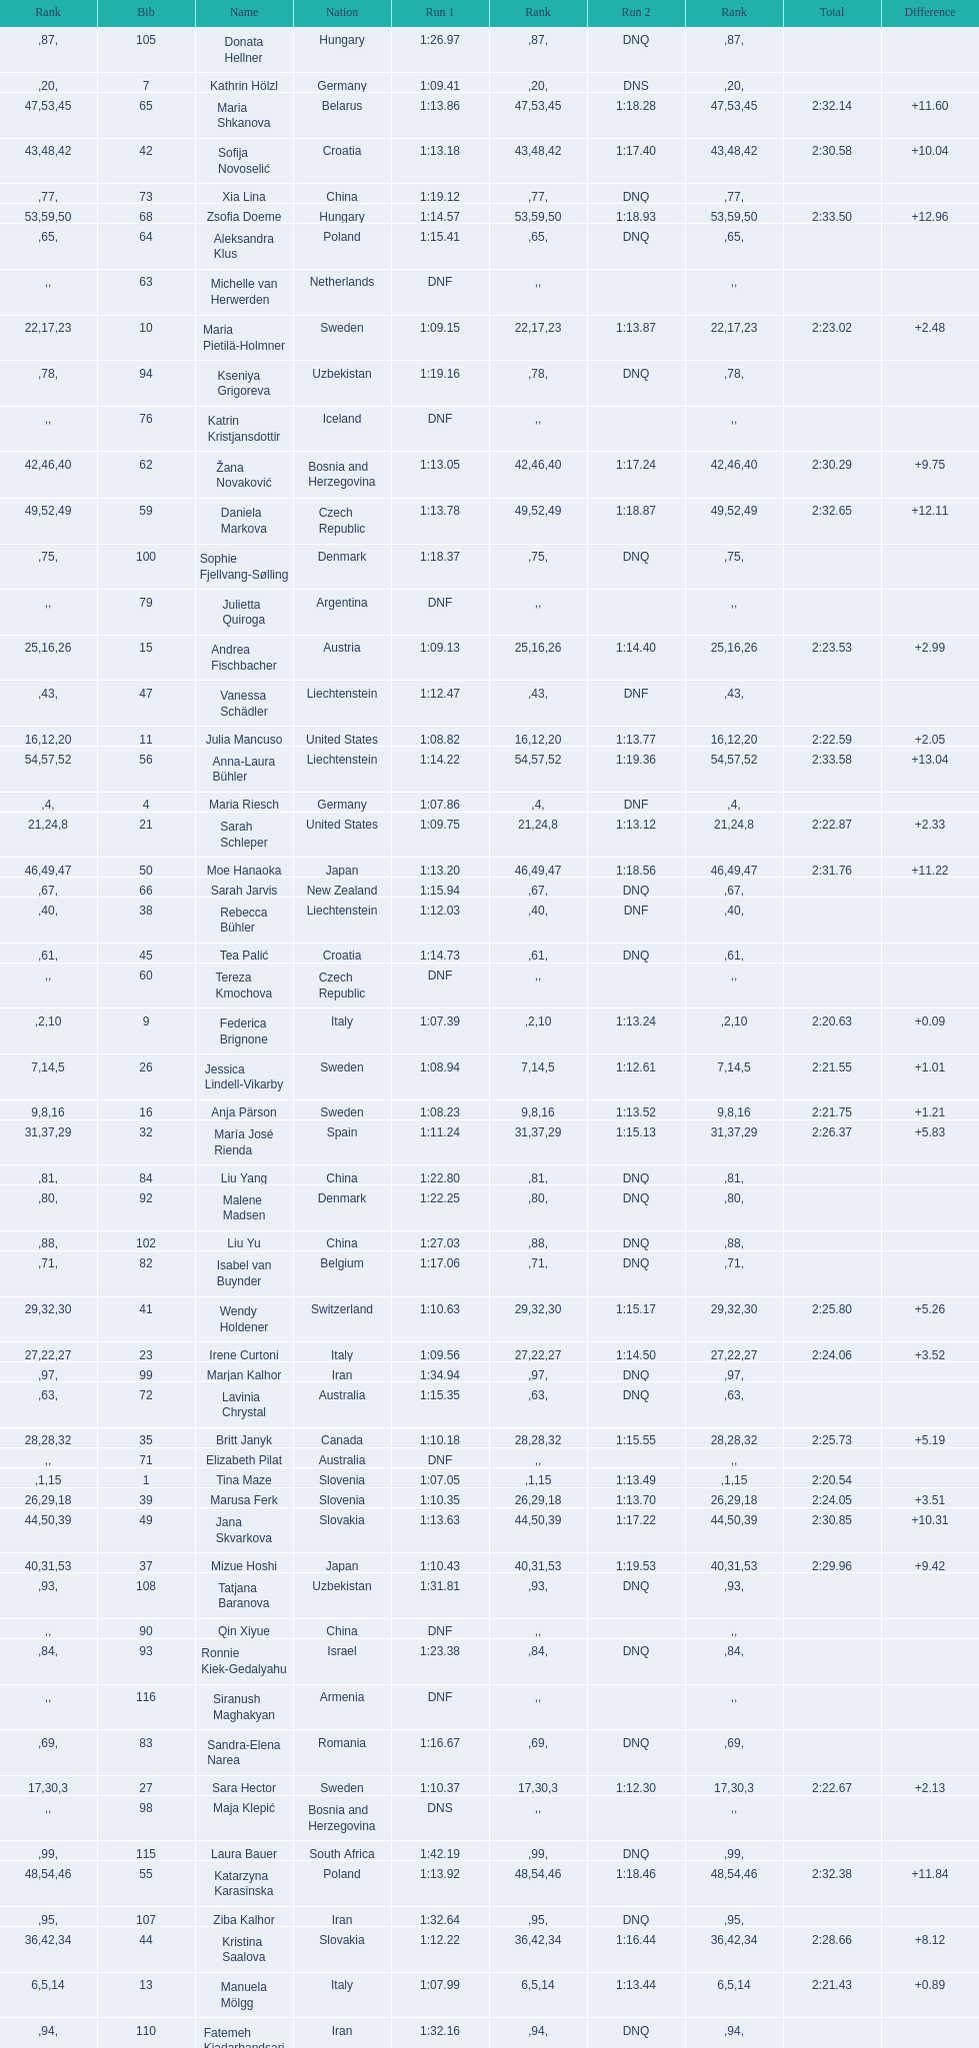How many total names are there? 116. Can you parse all the data within this table? {'header': ['Rank', 'Bib', 'Name', 'Nation', 'Run 1', 'Rank', 'Run 2', 'Rank', 'Total', 'Difference'], 'rows': [['', '105', 'Donata Hellner', 'Hungary', '1:26.97', '87', 'DNQ', '', '', ''], ['', '7', 'Kathrin Hölzl', 'Germany', '1:09.41', '20', 'DNS', '', '', ''], ['47', '65', 'Maria Shkanova', 'Belarus', '1:13.86', '53', '1:18.28', '45', '2:32.14', '+11.60'], ['43', '42', 'Sofija Novoselić', 'Croatia', '1:13.18', '48', '1:17.40', '42', '2:30.58', '+10.04'], ['', '73', 'Xia Lina', 'China', '1:19.12', '77', 'DNQ', '', '', ''], ['53', '68', 'Zsofia Doeme', 'Hungary', '1:14.57', '59', '1:18.93', '50', '2:33.50', '+12.96'], ['', '64', 'Aleksandra Klus', 'Poland', '1:15.41', '65', 'DNQ', '', '', ''], ['', '63', 'Michelle van Herwerden', 'Netherlands', 'DNF', '', '', '', '', ''], ['22', '10', 'Maria Pietilä-Holmner', 'Sweden', '1:09.15', '17', '1:13.87', '23', '2:23.02', '+2.48'], ['', '94', 'Kseniya Grigoreva', 'Uzbekistan', '1:19.16', '78', 'DNQ', '', '', ''], ['', '76', 'Katrin Kristjansdottir', 'Iceland', 'DNF', '', '', '', '', ''], ['42', '62', 'Žana Novaković', 'Bosnia and Herzegovina', '1:13.05', '46', '1:17.24', '40', '2:30.29', '+9.75'], ['49', '59', 'Daniela Markova', 'Czech Republic', '1:13.78', '52', '1:18.87', '49', '2:32.65', '+12.11'], ['', '100', 'Sophie Fjellvang-Sølling', 'Denmark', '1:18.37', '75', 'DNQ', '', '', ''], ['', '79', 'Julietta Quiroga', 'Argentina', 'DNF', '', '', '', '', ''], ['25', '15', 'Andrea Fischbacher', 'Austria', '1:09.13', '16', '1:14.40', '26', '2:23.53', '+2.99'], ['', '47', 'Vanessa Schädler', 'Liechtenstein', '1:12.47', '43', 'DNF', '', '', ''], ['16', '11', 'Julia Mancuso', 'United States', '1:08.82', '12', '1:13.77', '20', '2:22.59', '+2.05'], ['54', '56', 'Anna-Laura Bühler', 'Liechtenstein', '1:14.22', '57', '1:19.36', '52', '2:33.58', '+13.04'], ['', '4', 'Maria Riesch', 'Germany', '1:07.86', '4', 'DNF', '', '', ''], ['21', '21', 'Sarah Schleper', 'United States', '1:09.75', '24', '1:13.12', '8', '2:22.87', '+2.33'], ['46', '50', 'Moe Hanaoka', 'Japan', '1:13.20', '49', '1:18.56', '47', '2:31.76', '+11.22'], ['', '66', 'Sarah Jarvis', 'New Zealand', '1:15.94', '67', 'DNQ', '', '', ''], ['', '38', 'Rebecca Bühler', 'Liechtenstein', '1:12.03', '40', 'DNF', '', '', ''], ['', '45', 'Tea Palić', 'Croatia', '1:14.73', '61', 'DNQ', '', '', ''], ['', '60', 'Tereza Kmochova', 'Czech Republic', 'DNF', '', '', '', '', ''], ['', '9', 'Federica Brignone', 'Italy', '1:07.39', '2', '1:13.24', '10', '2:20.63', '+0.09'], ['7', '26', 'Jessica Lindell-Vikarby', 'Sweden', '1:08.94', '14', '1:12.61', '5', '2:21.55', '+1.01'], ['9', '16', 'Anja Pärson', 'Sweden', '1:08.23', '8', '1:13.52', '16', '2:21.75', '+1.21'], ['31', '32', 'María José Rienda', 'Spain', '1:11.24', '37', '1:15.13', '29', '2:26.37', '+5.83'], ['', '84', 'Liu Yang', 'China', '1:22.80', '81', 'DNQ', '', '', ''], ['', '92', 'Malene Madsen', 'Denmark', '1:22.25', '80', 'DNQ', '', '', ''], ['', '102', 'Liu Yu', 'China', '1:27.03', '88', 'DNQ', '', '', ''], ['', '82', 'Isabel van Buynder', 'Belgium', '1:17.06', '71', 'DNQ', '', '', ''], ['29', '41', 'Wendy Holdener', 'Switzerland', '1:10.63', '32', '1:15.17', '30', '2:25.80', '+5.26'], ['27', '23', 'Irene Curtoni', 'Italy', '1:09.56', '22', '1:14.50', '27', '2:24.06', '+3.52'], ['', '99', 'Marjan Kalhor', 'Iran', '1:34.94', '97', 'DNQ', '', '', ''], ['', '72', 'Lavinia Chrystal', 'Australia', '1:15.35', '63', 'DNQ', '', '', ''], ['28', '35', 'Britt Janyk', 'Canada', '1:10.18', '28', '1:15.55', '32', '2:25.73', '+5.19'], ['', '71', 'Elizabeth Pilat', 'Australia', 'DNF', '', '', '', '', ''], ['', '1', 'Tina Maze', 'Slovenia', '1:07.05', '1', '1:13.49', '15', '2:20.54', ''], ['26', '39', 'Marusa Ferk', 'Slovenia', '1:10.35', '29', '1:13.70', '18', '2:24.05', '+3.51'], ['44', '49', 'Jana Skvarkova', 'Slovakia', '1:13.63', '50', '1:17.22', '39', '2:30.85', '+10.31'], ['40', '37', 'Mizue Hoshi', 'Japan', '1:10.43', '31', '1:19.53', '53', '2:29.96', '+9.42'], ['', '108', 'Tatjana Baranova', 'Uzbekistan', '1:31.81', '93', 'DNQ', '', '', ''], ['', '90', 'Qin Xiyue', 'China', 'DNF', '', '', '', '', ''], ['', '93', 'Ronnie Kiek-Gedalyahu', 'Israel', '1:23.38', '84', 'DNQ', '', '', ''], ['', '116', 'Siranush Maghakyan', 'Armenia', 'DNF', '', '', '', '', ''], ['', '83', 'Sandra-Elena Narea', 'Romania', '1:16.67', '69', 'DNQ', '', '', ''], ['17', '27', 'Sara Hector', 'Sweden', '1:10.37', '30', '1:12.30', '3', '2:22.67', '+2.13'], ['', '98', 'Maja Klepić', 'Bosnia and Herzegovina', 'DNS', '', '', '', '', ''], ['', '115', 'Laura Bauer', 'South Africa', '1:42.19', '99', 'DNQ', '', '', ''], ['48', '55', 'Katarzyna Karasinska', 'Poland', '1:13.92', '54', '1:18.46', '46', '2:32.38', '+11.84'], ['', '107', 'Ziba Kalhor', 'Iran', '1:32.64', '95', 'DNQ', '', '', ''], ['36', '44', 'Kristina Saalova', 'Slovakia', '1:12.22', '42', '1:16.44', '34', '2:28.66', '+8.12'], ['6', '13', 'Manuela Mölgg', 'Italy', '1:07.99', '5', '1:13.44', '14', '2:21.43', '+0.89'], ['', '110', 'Fatemeh Kiadarbandsari', 'Iran', '1:32.16', '94', 'DNQ', '', '', ''], ['', '69', 'Iris Gudmundsdottir', 'Iceland', '1:13.93', '55', 'DNF', '', '', ''], ['38', '52', 'Jana Gantnerova', 'Slovakia', '1:12.01', '39', '1:17.29', '41', '2:29.30', '+8.76'], ['20', '17', 'Lara Gut', 'Switzerland', '1:08.91', '13', '1:13.92', '24', '2:22.83', '+2.29'], ['50', '58', 'Nevena Ignjatović', 'Serbia', '1:14.38', '58', '1:18.56', '47', '2:32.94', '+12.40'], ['', '95', 'Ornella Oettl Reyes', 'Peru', '1:18.61', '76', 'DNQ', '', '', ''], ['', '75', 'Salome Bancora', 'Argentina', '1:23.08', '83', 'DNQ', '', '', ''], ['', '88', 'Nicole Valcareggi', 'Greece', '1:18.19', '74', 'DNQ', '', '', ''], ['', '33', 'Agniezska Gasienica Daniel', 'Poland', 'DNF', '', '', '', '', ''], ['', '104', 'Paraskevi Mavridou', 'Greece', '1:32.83', '96', 'DNQ', '', '', ''], ['', '106', 'Svetlana Baranova', 'Uzbekistan', '1:30.62', '92', 'DNQ', '', '', ''], ['41', '34', 'Emi Hasegawa', 'Japan', '1:12.67', '44', '1:17.58', '43', '2:30.25', '+9.71'], ['19', '29', 'Anne-Sophie Barthet', 'France', '1:09.55', '21', '1:13.18', '9', '2:22.73', '+2.19'], ['', '113', 'Anne Libak Nielsen', 'Denmark', '1:25.08', '86', 'DNQ', '', '', ''], ['', '18', 'Fabienne Suter', 'Switzerland', 'DNS', '', '', '', '', ''], ['14', '12', 'Anemone Marmottan', 'France', '1:08.54', '10', '1:13.80', '21', '2:22.34', '+1.80'], ['18', '24', 'Lena Dürr', 'Germany', '1:08.94', '14', '1:13.75', '19', '2:22.69', '+2.15'], ['4', '20', 'Denise Karbon', 'Italy', '1:08.24', '9', '1:13.04', '7', '2:21.28', '+0.74'], ['', '96', 'Chiara Marano', 'Brazil', '1:24.16', '85', 'DNQ', '', '', ''], ['', '111', 'Sarah Ekmekejian', 'Lebanon', '1:42.22', '100', 'DNQ', '', '', ''], ['52', '77', 'Bogdana Matsotska', 'Ukraine', '1:14.21', '56', '1:19.18', '51', '2:33.39', '+12.85'], ['30', '28', 'Veronika Staber', 'Germany', '1:10.80', '33', '1:15.16', '28', '2:25.96', '+5.42'], ['', '78', 'Nino Tsiklauri', 'Georgia', '1:15.54', '66', 'DNQ', '', '', ''], ['', '70', 'Maya Harrisson', 'Brazil', 'DNF', '', '', '', '', ''], ['8', '19', 'Marlies Schild', 'Austria', '1:09.16', '18', '1:12.58', '4', '2:21.74', '+1.20'], ['5', '6', 'Viktoria Rebensburg', 'Germany', '1:08.04', '6', '1:13.38', '13', '2:21.42', '+0.88'], ['', '91', 'Yom Hirshfeld', 'Israel', '1:22.87', '82', 'DNQ', '', '', ''], ['', '85', 'Iulia Petruta Craciun', 'Romania', '1:16.80', '70', 'DNQ', '', '', ''], ['45', '40', 'Maria Belen Simari Birkner', 'Argentina', '1:13.14', '47', '1:17.84', '44', '2:30.98', '+10.44'], ['23', '22', 'Marie-Michèle Gagnon', 'Canada', '1:09.95', '27', '1:13.37', '12', '2:23.32', '+2.78'], ['37', '51', 'Katerina Paulathova', 'Czech Republic', '1:12.10', '41', '1:16.71', '38', '2:28.81', '+8.27'], ['51', '80', 'Maria Kirkova', 'Bulgaria', '1:13.70', '51', '1:19.56', '54', '2:33.26', '+12.72'], ['39', '46', 'Vladislava Bureeva', 'Russia', '1:12.83', '45', '1:16.63', '37', '2:29.46', '+8.92'], ['13', '2', 'Tanja Poutiainen', 'Finland', '1:08.59', '11', '1:13.29', '11', '2:21.88', '+1.34'], ['10', '8', 'Elisabeth Görgl', 'Austria', '1:07.76', '3', '1:14.03', '25', '2:21.79', '+1.25'], ['12', '5', 'Kathrin Zettel', 'Austria', '1:08.04', '6', '1:13.80', '21', '2:21.84', '+1.30'], ['', '81', 'Lelde Gasuna', 'Latvia', '1:15.37', '64', 'DNQ', '', '', ''], ['', '86', 'Kristina Krone', 'Puerto Rico', '1:17.93', '73', 'DNQ', '', '', ''], ['', '103', 'Szelina Hellner', 'Hungary', '1:27.27', '90', 'DNQ', '', '', ''], ['15', '31', 'Veronika Zuzulova', 'Slovakia', '1:09.76', '25', '1:12.81', '6', '2:22.57', '+2.03'], ['33', '36', 'Carolina Ruiz Castillo', 'Spain', '1:10.93', '34', '1:15.98', '33', '2:26.91', '+6.37'], ['10', '14', 'Taïna Barioz', 'France', '1:09.59', '23', '1:12.20', '2', '2:21.79', '+1.25'], ['', '87', 'Tugba Dasdemir', 'Turkey', '1:21.50', '79', 'DNQ', '', '', ''], ['34', '30', 'Megan McJames', 'United States', '1:11.13', '36', '1:16.49', '35', '2:27.62', '+7.08'], ['', '74', 'Macarena Simari Birkner', 'Argentina', '1:15.18', '62', 'DNQ', '', '', ''], ['', '57', 'Brittany Phelan', 'Canada', 'DNF', '', '', '', '', ''], ['', '114', 'Irina Volkova', 'Kyrgyzstan', '1:29.73', '91', 'DNQ', '', '', ''], ['', '54', 'Mireia Gutierrez', 'Andorra', 'DNF', '', '', '', '', ''], ['', '89', 'Evija Benhena', 'Latvia', 'DNF', '', '', '', '', ''], ['35', '43', 'Denise Feierabend', 'Switzerland', '1:11.37', '38', '1:16.61', '36', '2:27.98', '+7.44'], ['32', '48', 'Andrea Jardi', 'Spain', '1:11.03', '35', '1:15.52', '31', '2:26.55', '+6.01'], ['', '53', 'Karolina Chrapek', 'Poland', 'DNF', '', '', '', '', ''], ['55', '67', 'Martina Dubovska', 'Czech Republic', '1:14.62', '60', '1:19.95', '55', '2:34.57', '+14.03'], ['24', '25', 'Marie-Pier Prefontaine', 'Canada', '1:09.91', '26', '1:13.58', '17', '2:23.49', '+2.95'], ['', '109', 'Lida Zvoznikova', 'Kyrgyzstan', '1:27.17', '89', 'DNQ', '', '', ''], ['', '3', 'Tessa Worley', 'France', '1:09.17', '19', '1:11.85', '1', '2:21.02', '+0.48'], ['', '61', 'Anna Berecz', 'Hungary', '1:15.95', '68', 'DNQ', '', '', ''], ['', '112', 'Mitra Kalhor', 'Iran', '1:37.93', '98', 'DNQ', '', '', ''], ['', '101', 'Sophia Ralli', 'Greece', 'DNF', '', '', '', '', ''], ['', '97', 'Liene Fimbauere', 'Latvia', '1:17.83', '72', 'DNQ', '', '', '']]} 